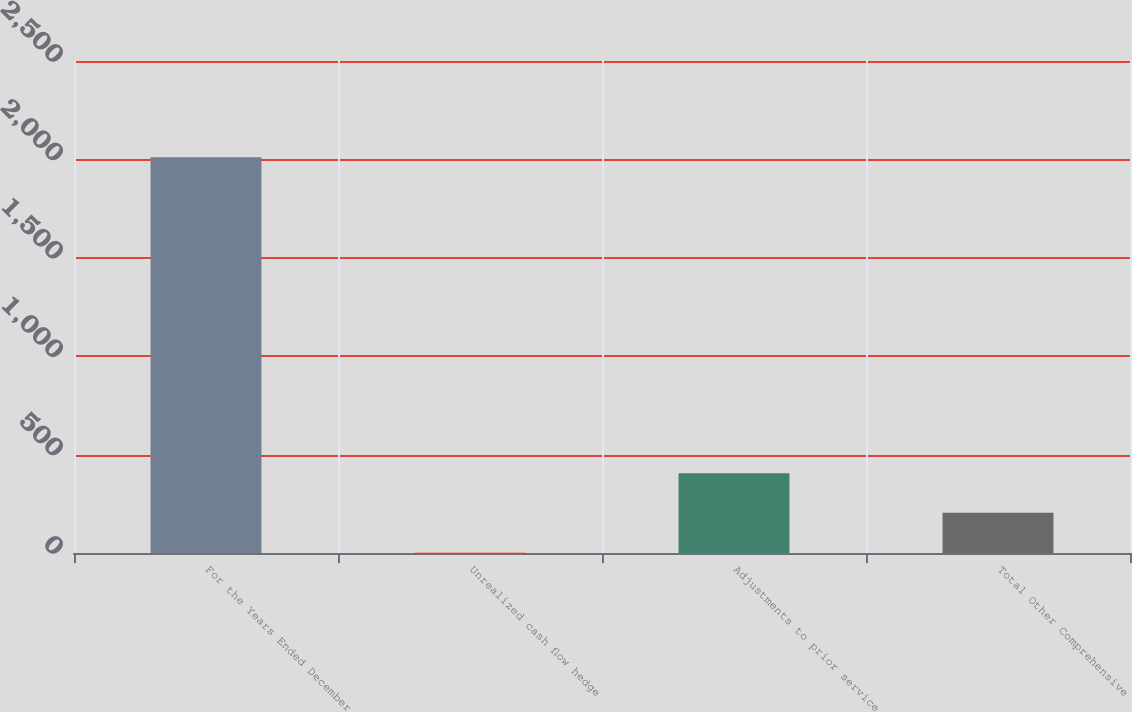Convert chart. <chart><loc_0><loc_0><loc_500><loc_500><bar_chart><fcel>For the Years Ended December<fcel>Unrealized cash flow hedge<fcel>Adjustments to prior service<fcel>Total Other Comprehensive<nl><fcel>2011<fcel>4.3<fcel>405.64<fcel>204.97<nl></chart> 